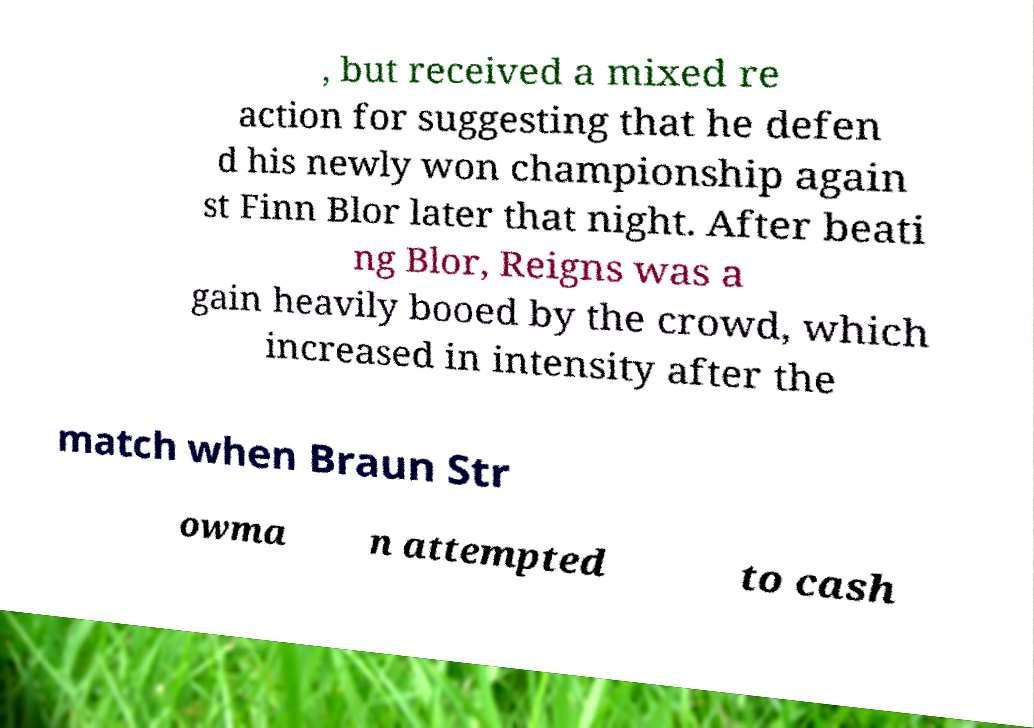Please identify and transcribe the text found in this image. , but received a mixed re action for suggesting that he defen d his newly won championship again st Finn Blor later that night. After beati ng Blor, Reigns was a gain heavily booed by the crowd, which increased in intensity after the match when Braun Str owma n attempted to cash 